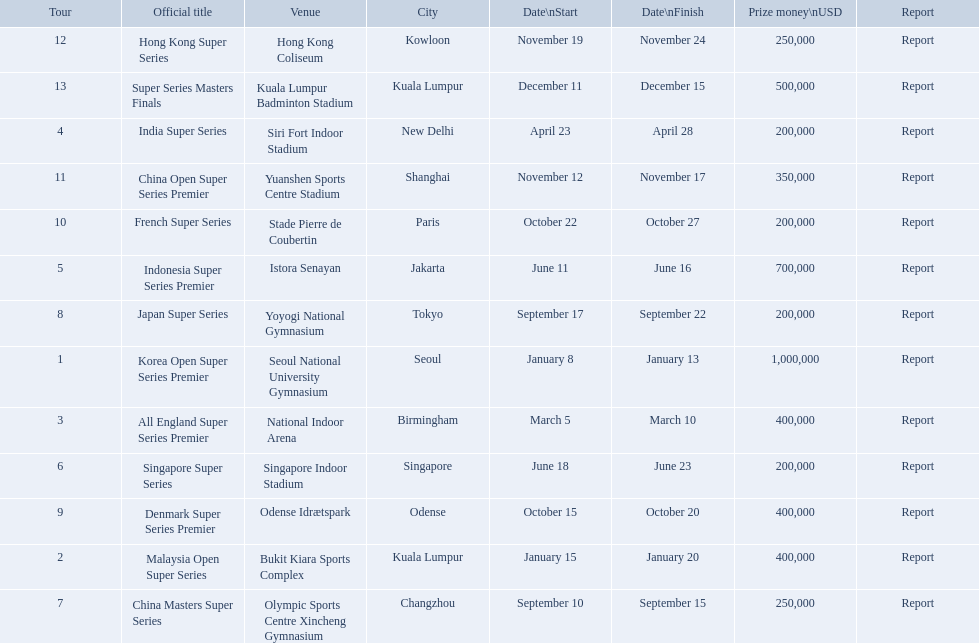What were the titles of the 2013 bwf super series? Korea Open Super Series Premier, Malaysia Open Super Series, All England Super Series Premier, India Super Series, Indonesia Super Series Premier, Singapore Super Series, China Masters Super Series, Japan Super Series, Denmark Super Series Premier, French Super Series, China Open Super Series Premier, Hong Kong Super Series, Super Series Masters Finals. Which were in december? Super Series Masters Finals. 